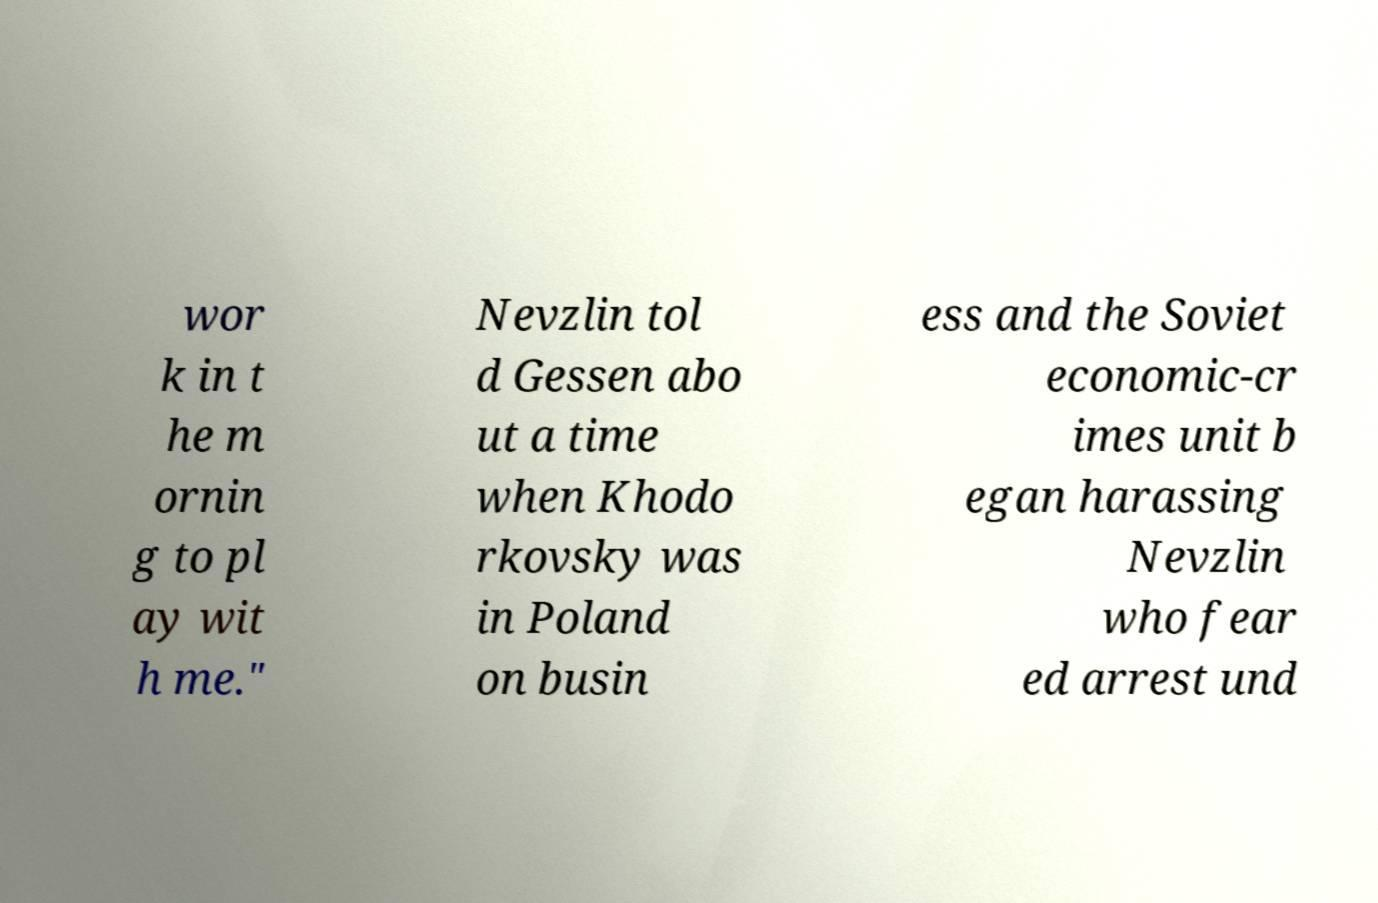Please read and relay the text visible in this image. What does it say? wor k in t he m ornin g to pl ay wit h me." Nevzlin tol d Gessen abo ut a time when Khodo rkovsky was in Poland on busin ess and the Soviet economic-cr imes unit b egan harassing Nevzlin who fear ed arrest und 